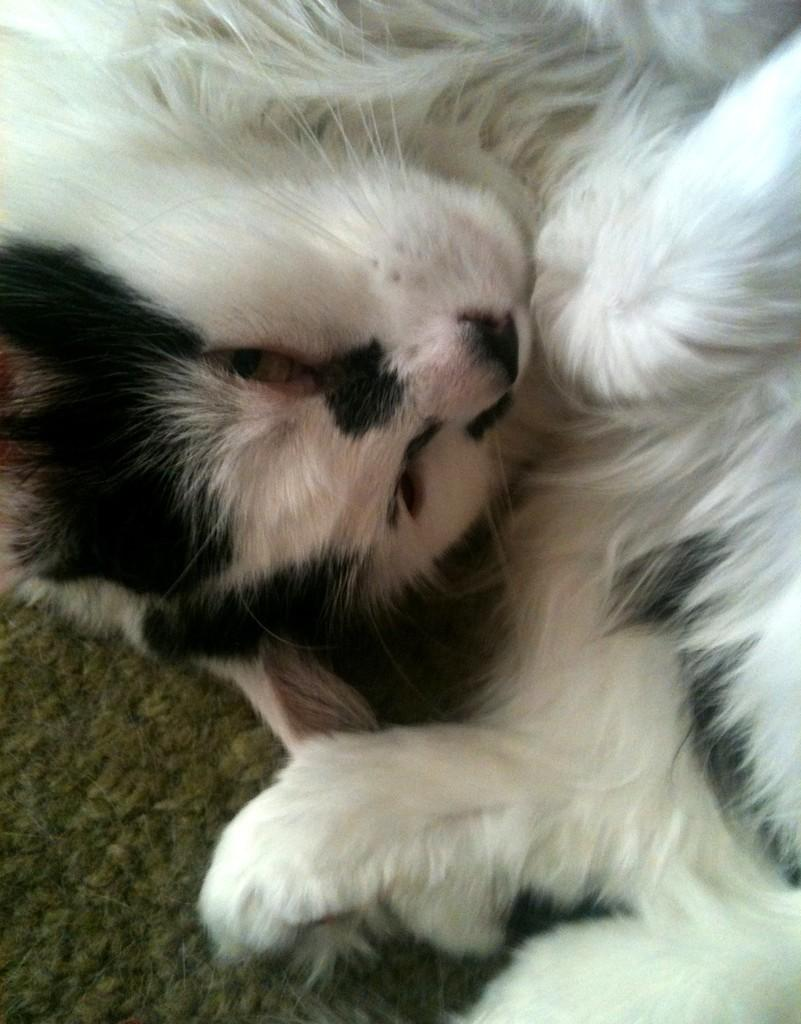What type of animal is in the image? The animal in the image has a white and black color pattern. Can you describe the color pattern of the animal? The animal has a white and black color pattern. What is the surface the animal is on? The animal is on a brown surface. Is there a stream of water flowing through the image? There is no stream of water present in the image. Can you locate a map in the image? There is no map present in the image. 